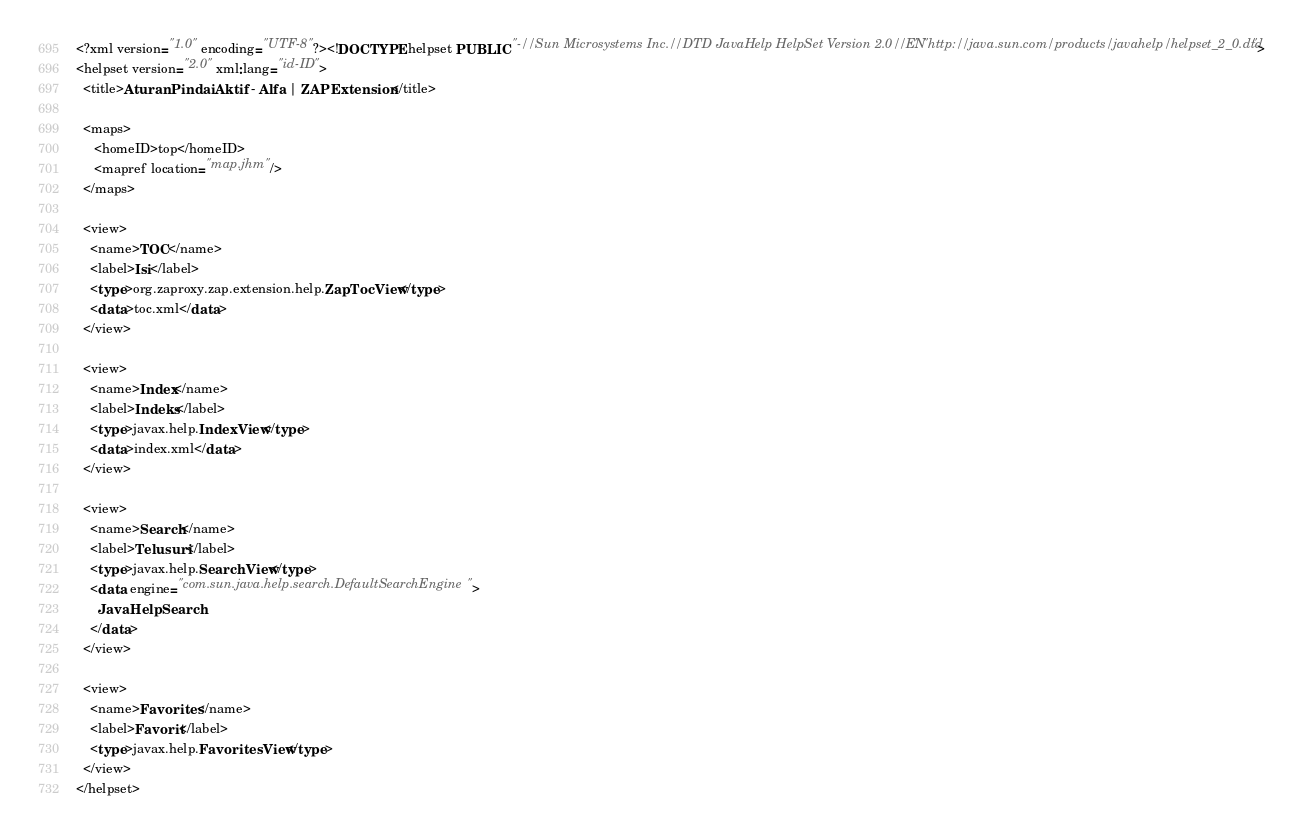<code> <loc_0><loc_0><loc_500><loc_500><_Haskell_><?xml version="1.0" encoding="UTF-8"?><!DOCTYPE helpset PUBLIC "-//Sun Microsystems Inc.//DTD JavaHelp HelpSet Version 2.0//EN" "http://java.sun.com/products/javahelp/helpset_2_0.dtd">
<helpset version="2.0" xml:lang="id-ID">
  <title>Aturan Pindai Aktif - Alfa | ZAP Extension</title>

  <maps>
     <homeID>top</homeID>
     <mapref location="map.jhm"/>
  </maps>

  <view>
    <name>TOC</name>
    <label>Isi</label>
    <type>org.zaproxy.zap.extension.help.ZapTocView</type>
    <data>toc.xml</data>
  </view>

  <view>
    <name>Index</name>
    <label>Indeks</label>
    <type>javax.help.IndexView</type>
    <data>index.xml</data>
  </view>

  <view>
    <name>Search</name>
    <label>Telusuri</label>
    <type>javax.help.SearchView</type>
    <data engine="com.sun.java.help.search.DefaultSearchEngine">
      JavaHelpSearch
    </data>
  </view>

  <view>
    <name>Favorites</name>
    <label>Favorit</label>
    <type>javax.help.FavoritesView</type>
  </view>
</helpset></code> 